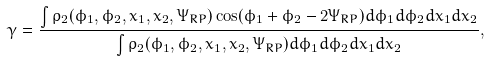<formula> <loc_0><loc_0><loc_500><loc_500>\gamma = \frac { \int \rho _ { 2 } ( \phi _ { 1 } , \phi _ { 2 } , x _ { 1 } , x _ { 2 } , \Psi _ { R P } ) \cos ( \phi _ { 1 } + \phi _ { 2 } - 2 \Psi _ { R P } ) d \phi _ { 1 } d \phi _ { 2 } d x _ { 1 } d x _ { 2 } } { \int \rho _ { 2 } ( \phi _ { 1 } , \phi _ { 2 } , x _ { 1 } , x _ { 2 } , \Psi _ { R P } ) d \phi _ { 1 } d \phi _ { 2 } d x _ { 1 } d x _ { 2 } } ,</formula> 